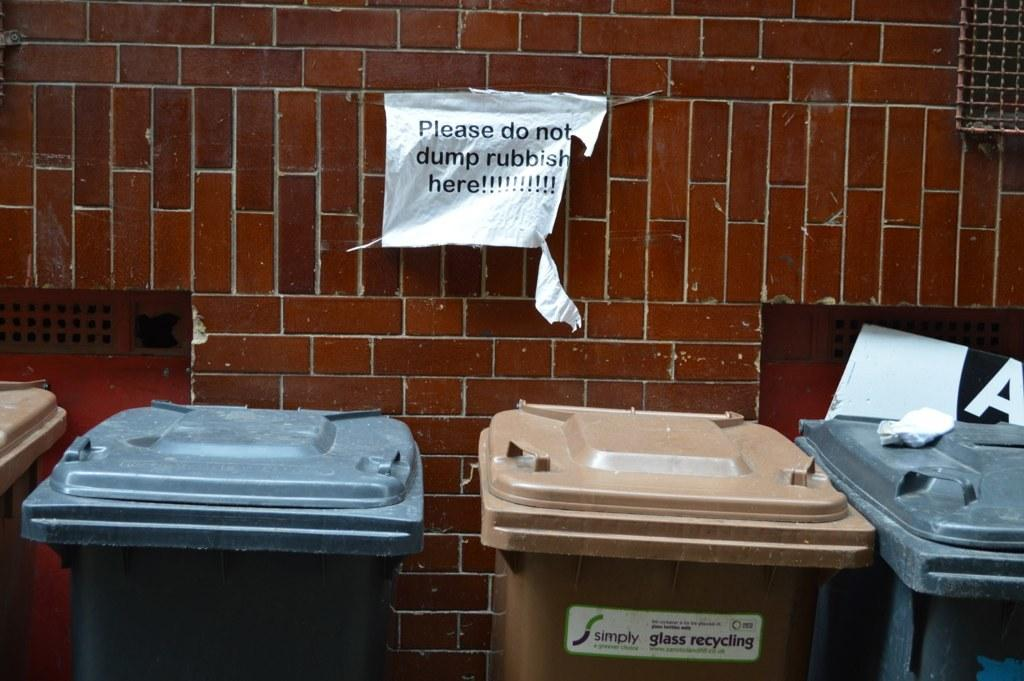<image>
Give a short and clear explanation of the subsequent image. White sign above the garbage cans which says "Please do not dump rubbish here". 